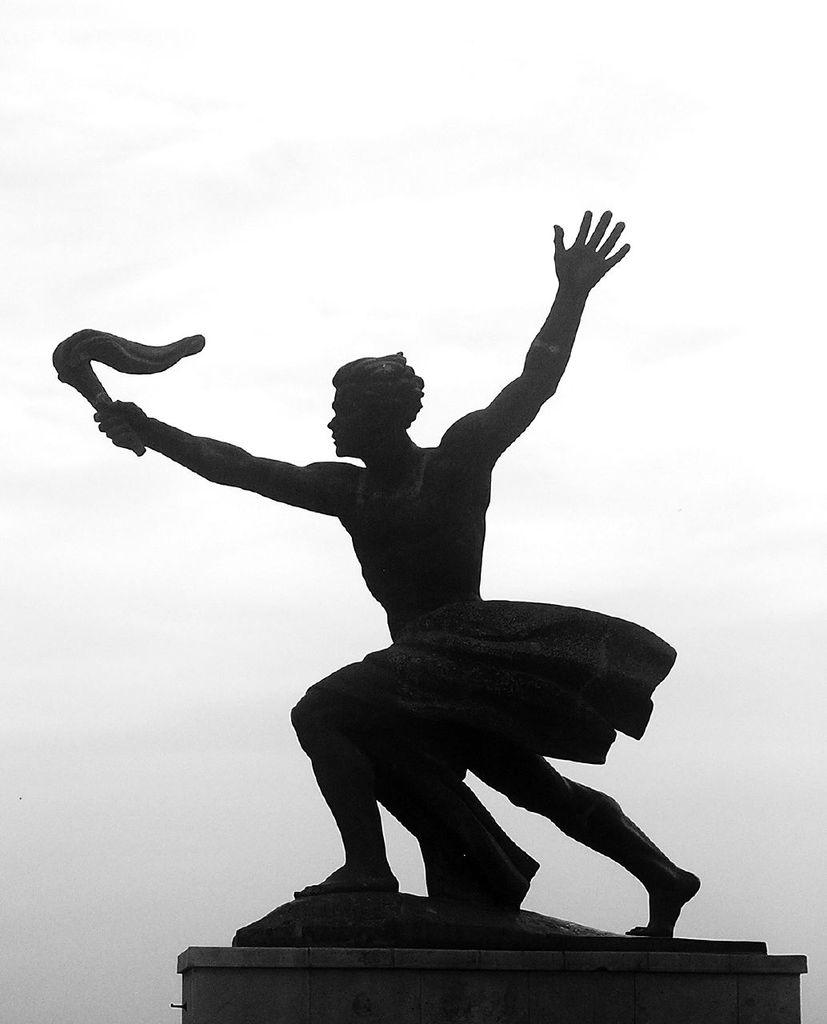What is the main subject in the picture? There is a statue in the picture. Can you describe the sky in the background? The sky in the background is cloudy. What type of cake is being smashed by the wren in the image? There is no cake or wren present in the image; it features a statue and a cloudy sky. 